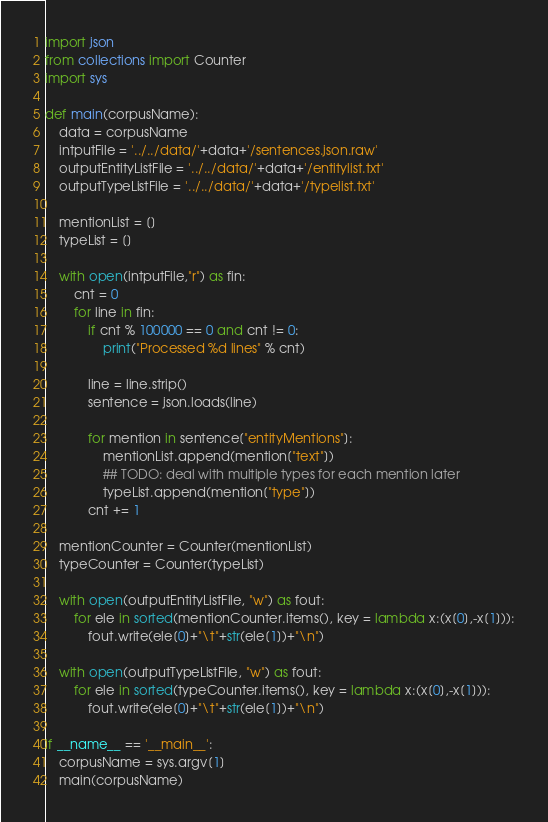Convert code to text. <code><loc_0><loc_0><loc_500><loc_500><_Python_>import json
from collections import Counter
import sys

def main(corpusName):
	data = corpusName
	intputFile = '../../data/'+data+'/sentences.json.raw'
	outputEntityListFile = '../../data/'+data+'/entitylist.txt'
	outputTypeListFile = '../../data/'+data+'/typelist.txt'

	mentionList = []
	typeList = []

	with open(intputFile,"r") as fin:
		cnt = 0
		for line in fin:
			if cnt % 100000 == 0 and cnt != 0:
				print("Processed %d lines" % cnt)

			line = line.strip()
			sentence = json.loads(line)

			for mention in sentence["entityMentions"]:
				mentionList.append(mention["text"])
				## TODO: deal with multiple types for each mention later
				typeList.append(mention["type"])
			cnt += 1

	mentionCounter = Counter(mentionList)
	typeCounter = Counter(typeList)

	with open(outputEntityListFile, "w") as fout:
		for ele in sorted(mentionCounter.items(), key = lambda x:(x[0],-x[1])):
			fout.write(ele[0]+"\t"+str(ele[1])+"\n")

	with open(outputTypeListFile, "w") as fout:
		for ele in sorted(typeCounter.items(), key = lambda x:(x[0],-x[1])):
			fout.write(ele[0]+"\t"+str(ele[1])+"\n")

if __name__ == '__main__':
	corpusName = sys.argv[1]
	main(corpusName)
</code> 